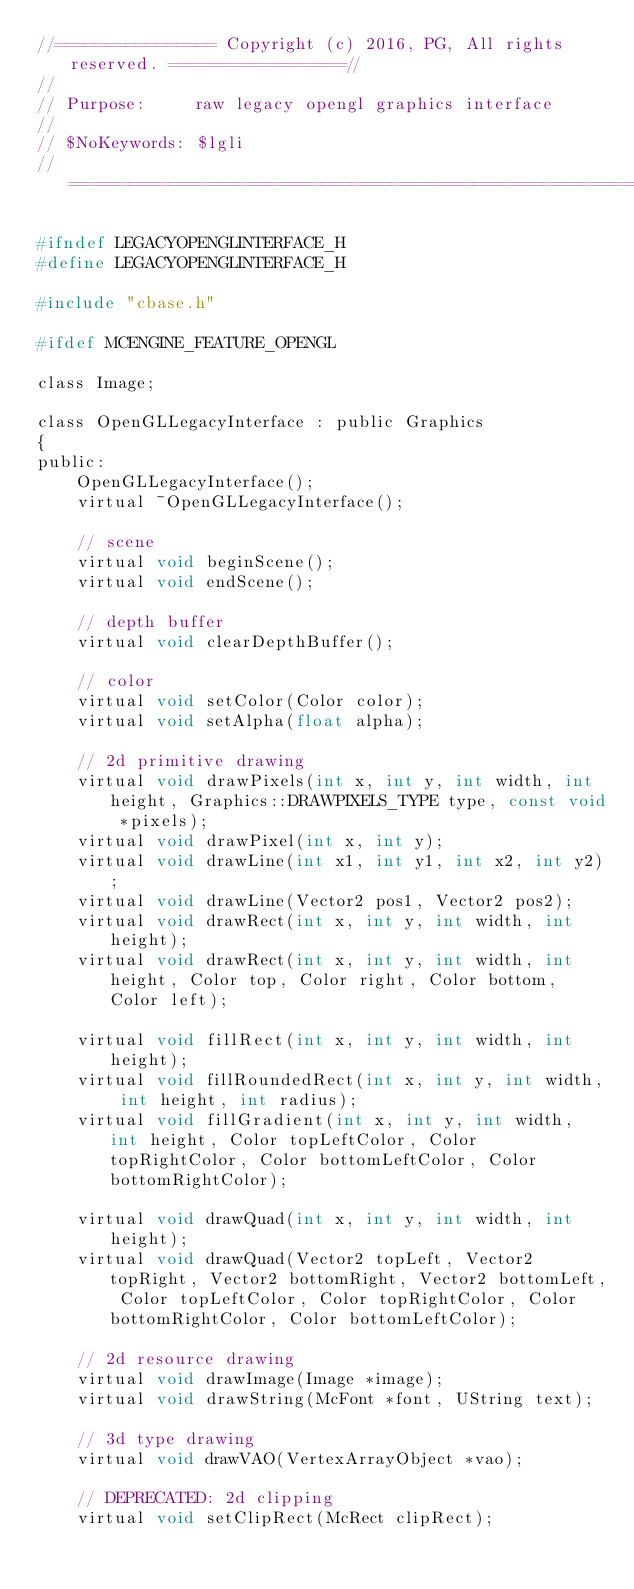<code> <loc_0><loc_0><loc_500><loc_500><_C_>//================ Copyright (c) 2016, PG, All rights reserved. =================//
//
// Purpose:		raw legacy opengl graphics interface
//
// $NoKeywords: $lgli
//===============================================================================//

#ifndef LEGACYOPENGLINTERFACE_H
#define LEGACYOPENGLINTERFACE_H

#include "cbase.h"

#ifdef MCENGINE_FEATURE_OPENGL

class Image;

class OpenGLLegacyInterface : public Graphics
{
public:
	OpenGLLegacyInterface();
	virtual ~OpenGLLegacyInterface();

	// scene
	virtual void beginScene();
	virtual void endScene();

	// depth buffer
	virtual void clearDepthBuffer();

	// color
	virtual void setColor(Color color);
	virtual void setAlpha(float alpha);

	// 2d primitive drawing
	virtual void drawPixels(int x, int y, int width, int height, Graphics::DRAWPIXELS_TYPE type, const void *pixels);
	virtual void drawPixel(int x, int y);
	virtual void drawLine(int x1, int y1, int x2, int y2);
	virtual void drawLine(Vector2 pos1, Vector2 pos2);
	virtual void drawRect(int x, int y, int width, int height);
	virtual void drawRect(int x, int y, int width, int height, Color top, Color right, Color bottom, Color left);

	virtual void fillRect(int x, int y, int width, int height);
	virtual void fillRoundedRect(int x, int y, int width, int height, int radius);
	virtual void fillGradient(int x, int y, int width, int height, Color topLeftColor, Color topRightColor, Color bottomLeftColor, Color bottomRightColor);

	virtual void drawQuad(int x, int y, int width, int height);
	virtual void drawQuad(Vector2 topLeft, Vector2 topRight, Vector2 bottomRight, Vector2 bottomLeft, Color topLeftColor, Color topRightColor, Color bottomRightColor, Color bottomLeftColor);

	// 2d resource drawing
	virtual void drawImage(Image *image);
	virtual void drawString(McFont *font, UString text);

	// 3d type drawing
	virtual void drawVAO(VertexArrayObject *vao);

	// DEPRECATED: 2d clipping
	virtual void setClipRect(McRect clipRect);</code> 